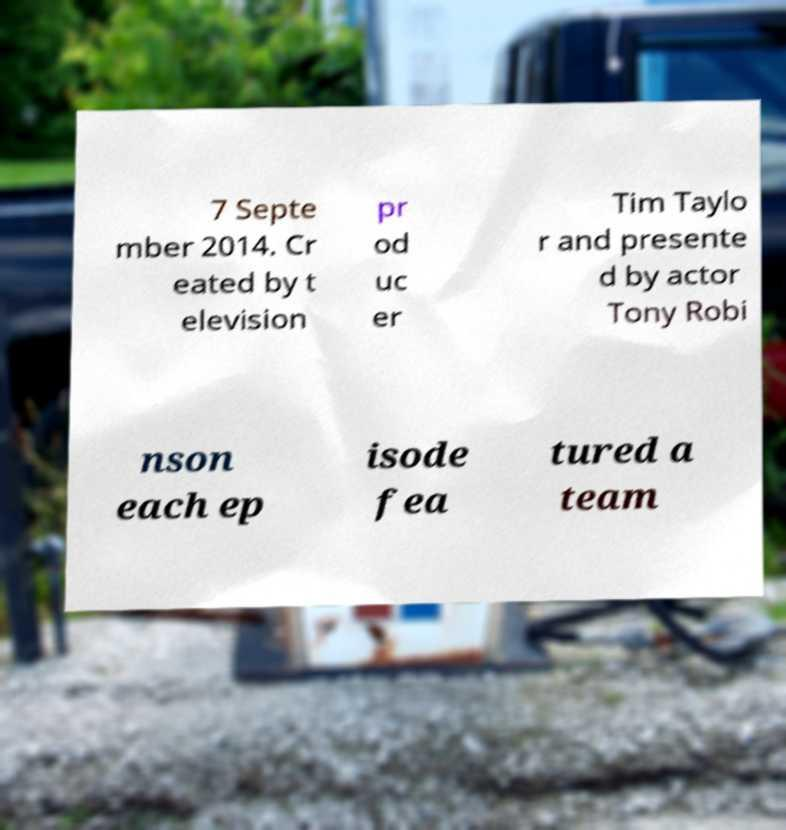Could you assist in decoding the text presented in this image and type it out clearly? 7 Septe mber 2014. Cr eated by t elevision pr od uc er Tim Taylo r and presente d by actor Tony Robi nson each ep isode fea tured a team 